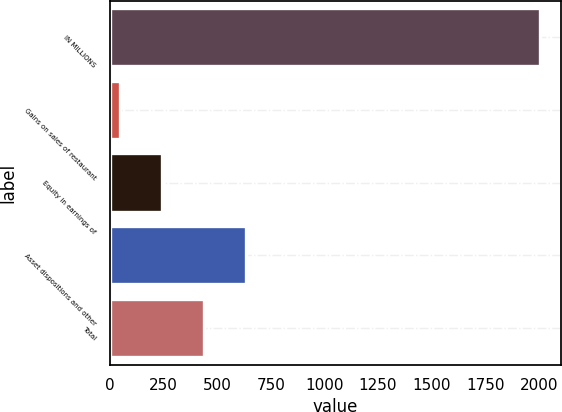Convert chart. <chart><loc_0><loc_0><loc_500><loc_500><bar_chart><fcel>IN MILLIONS<fcel>Gains on sales of restaurant<fcel>Equity in earnings of<fcel>Asset dispositions and other<fcel>Total<nl><fcel>2005<fcel>44.7<fcel>240.73<fcel>632.79<fcel>436.76<nl></chart> 